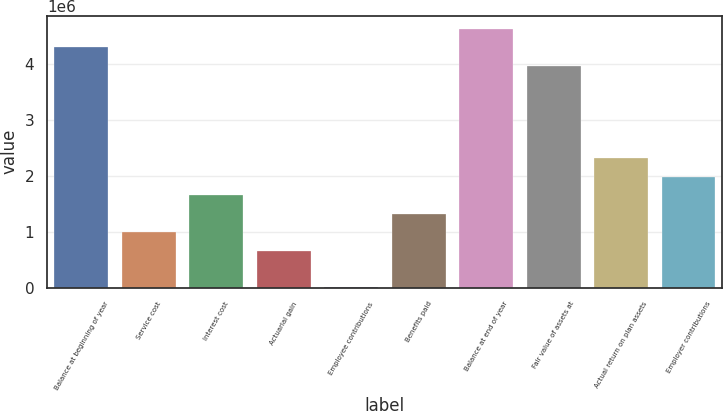Convert chart to OTSL. <chart><loc_0><loc_0><loc_500><loc_500><bar_chart><fcel>Balance at beginning of year<fcel>Service cost<fcel>Interest cost<fcel>Actuarial gain<fcel>Employee contributions<fcel>Benefits paid<fcel>Balance at end of year<fcel>Fair value of assets at<fcel>Actual return on plan assets<fcel>Employer contributions<nl><fcel>4.29664e+06<fcel>992226<fcel>1.65311e+06<fcel>661785<fcel>902<fcel>1.32267e+06<fcel>4.62708e+06<fcel>3.9662e+06<fcel>2.31399e+06<fcel>1.98355e+06<nl></chart> 